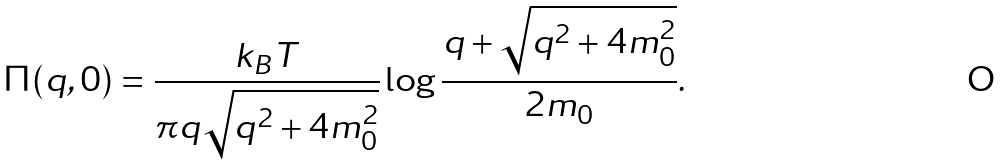Convert formula to latex. <formula><loc_0><loc_0><loc_500><loc_500>\Pi ( { q } , 0 ) = \frac { k _ { B } T } { \pi q \sqrt { q ^ { 2 } + 4 m ^ { 2 } _ { 0 } } } \log { \frac { q + \sqrt { q ^ { 2 } + 4 m ^ { 2 } _ { 0 } } } { 2 m _ { 0 } } } .</formula> 